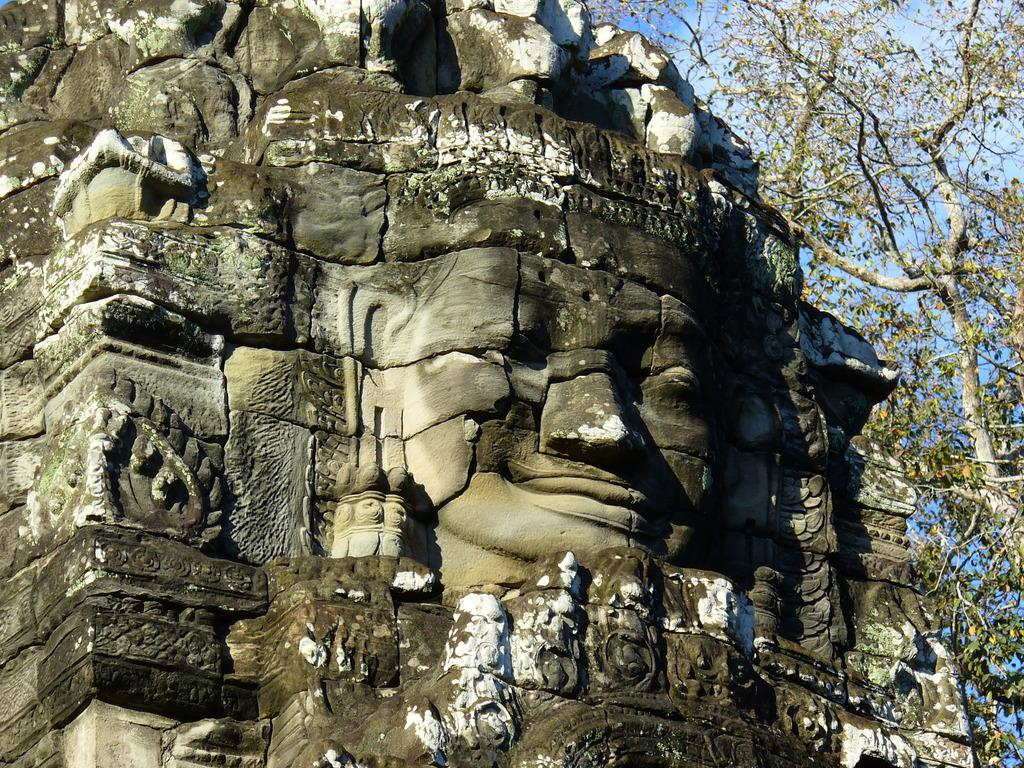What type of structure is in the image? There is a temple in the image. What can be seen on the wall in the center of the image? There is a human face on the wall in the center of the image. What type of vegetation is on the right side of the image? There are trees on the right side of the image. What part of the sky is visible in the image? The sky is visible in the top right corner of the image. Can you see a banana hanging from the tree in the image? There is no banana visible in the image; only trees are present. Is there a swing attached to the temple in the image? There is no swing present in the image; only the temple, human face, trees, and sky are visible. 